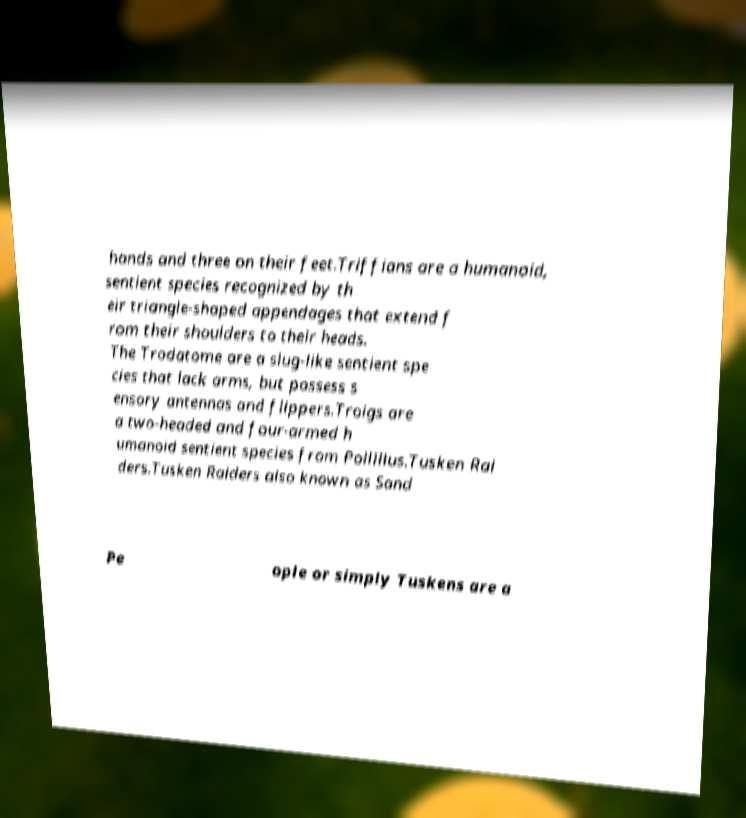Please read and relay the text visible in this image. What does it say? hands and three on their feet.Triffians are a humanoid, sentient species recognized by th eir triangle-shaped appendages that extend f rom their shoulders to their heads. The Trodatome are a slug-like sentient spe cies that lack arms, but possess s ensory antennas and flippers.Troigs are a two-headed and four-armed h umanoid sentient species from Pollillus.Tusken Rai ders.Tusken Raiders also known as Sand Pe ople or simply Tuskens are a 